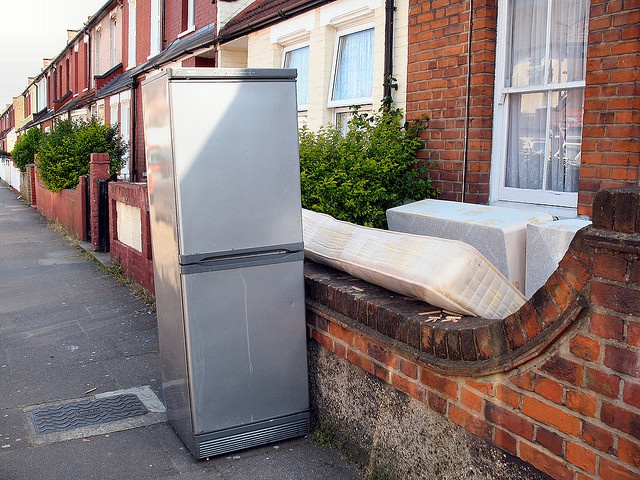Describe the objects in this image and their specific colors. I can see refrigerator in white, darkgray, and gray tones and bed in white, lightgray, and darkgray tones in this image. 